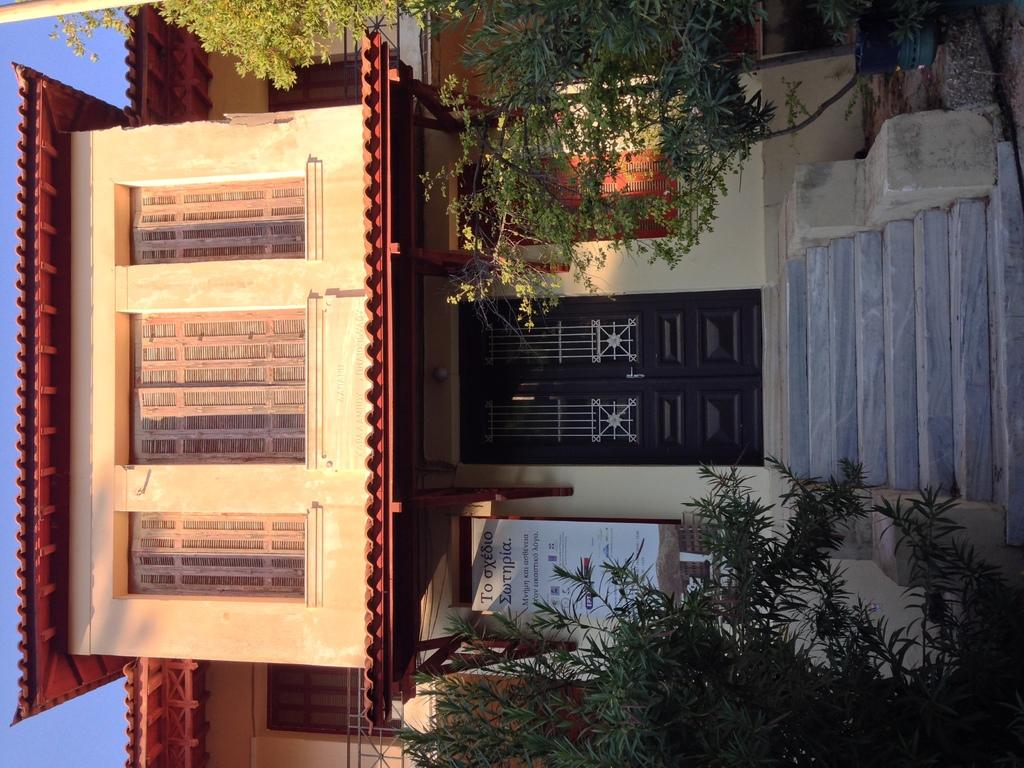What is the main structure in the middle of the image? There is a house in the middle of the image. What type of vegetation can be seen at the bottom of the image? There are trees at the bottom of the image. What type of hook is hanging from the tree in the image? There is no hook present in the image; it only features a house and trees. 